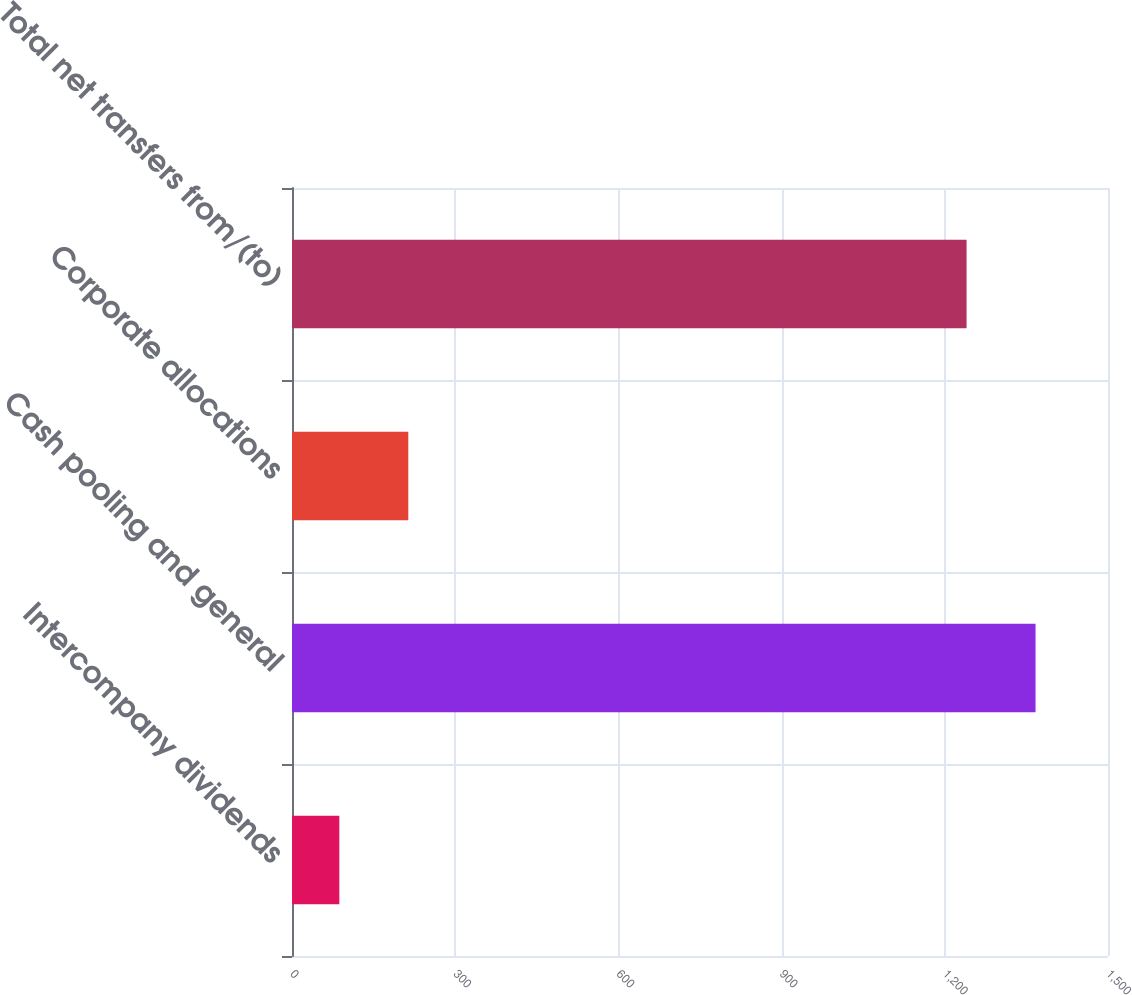Convert chart. <chart><loc_0><loc_0><loc_500><loc_500><bar_chart><fcel>Intercompany dividends<fcel>Cash pooling and general<fcel>Corporate allocations<fcel>Total net transfers from/(to)<nl><fcel>87<fcel>1366.8<fcel>213.8<fcel>1240<nl></chart> 